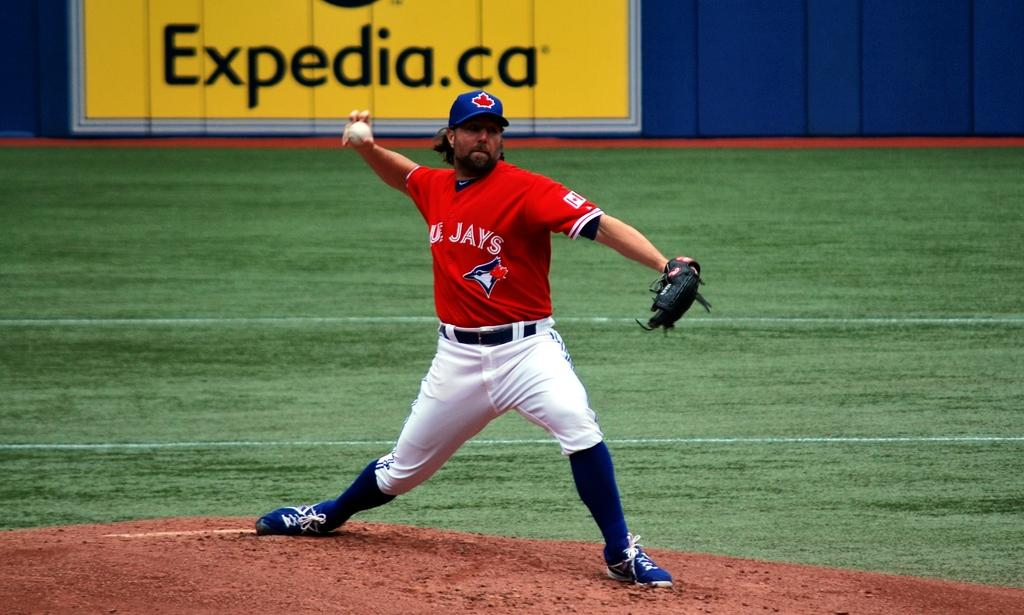<image>
Share a concise interpretation of the image provided. A player for the Toronto Blue Jays prepares to throw the ball. 